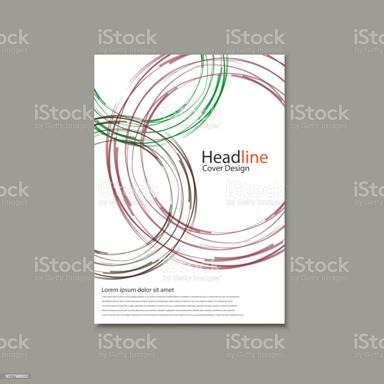How do the colors used in the brochure's design contribute to its overall aesthetic? The colors, primarily maroon and green, provide a striking contrast that enhances the brochure's visual appeal. The use of these colors also suggests a sense of freshness and creativity, appealing to viewers with a modern, artistic twist to traditional brochure designs. 